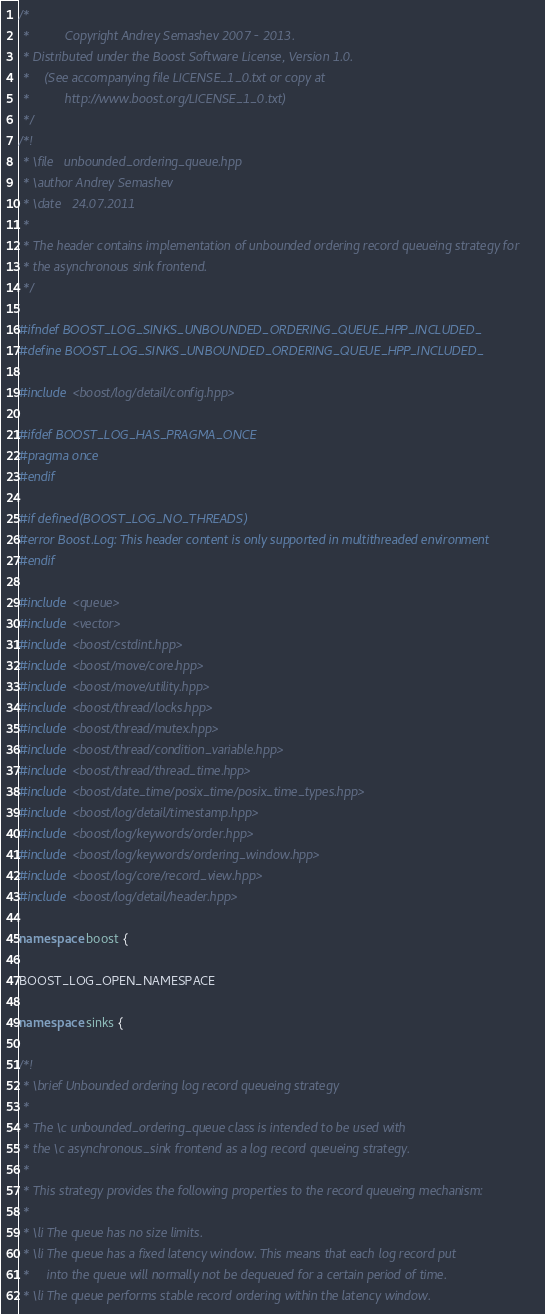Convert code to text. <code><loc_0><loc_0><loc_500><loc_500><_C++_>/*
 *          Copyright Andrey Semashev 2007 - 2013.
 * Distributed under the Boost Software License, Version 1.0.
 *    (See accompanying file LICENSE_1_0.txt or copy at
 *          http://www.boost.org/LICENSE_1_0.txt)
 */
/*!
 * \file   unbounded_ordering_queue.hpp
 * \author Andrey Semashev
 * \date   24.07.2011
 *
 * The header contains implementation of unbounded ordering record queueing strategy for
 * the asynchronous sink frontend.
 */

#ifndef BOOST_LOG_SINKS_UNBOUNDED_ORDERING_QUEUE_HPP_INCLUDED_
#define BOOST_LOG_SINKS_UNBOUNDED_ORDERING_QUEUE_HPP_INCLUDED_

#include <boost/log/detail/config.hpp>

#ifdef BOOST_LOG_HAS_PRAGMA_ONCE
#pragma once
#endif

#if defined(BOOST_LOG_NO_THREADS)
#error Boost.Log: This header content is only supported in multithreaded environment
#endif

#include <queue>
#include <vector>
#include <boost/cstdint.hpp>
#include <boost/move/core.hpp>
#include <boost/move/utility.hpp>
#include <boost/thread/locks.hpp>
#include <boost/thread/mutex.hpp>
#include <boost/thread/condition_variable.hpp>
#include <boost/thread/thread_time.hpp>
#include <boost/date_time/posix_time/posix_time_types.hpp>
#include <boost/log/detail/timestamp.hpp>
#include <boost/log/keywords/order.hpp>
#include <boost/log/keywords/ordering_window.hpp>
#include <boost/log/core/record_view.hpp>
#include <boost/log/detail/header.hpp>

namespace boost {

BOOST_LOG_OPEN_NAMESPACE

namespace sinks {

/*!
 * \brief Unbounded ordering log record queueing strategy
 *
 * The \c unbounded_ordering_queue class is intended to be used with
 * the \c asynchronous_sink frontend as a log record queueing strategy.
 *
 * This strategy provides the following properties to the record queueing mechanism:
 *
 * \li The queue has no size limits.
 * \li The queue has a fixed latency window. This means that each log record put
 *     into the queue will normally not be dequeued for a certain period of time.
 * \li The queue performs stable record ordering within the latency window.</code> 